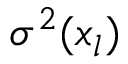<formula> <loc_0><loc_0><loc_500><loc_500>\sigma ^ { 2 } ( x _ { l } )</formula> 